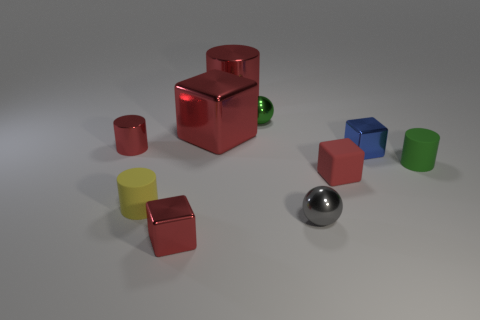Subtract all green spheres. How many red cubes are left? 3 Subtract all cubes. How many objects are left? 6 Add 1 red blocks. How many red blocks exist? 4 Subtract 0 brown balls. How many objects are left? 10 Subtract all big cubes. Subtract all tiny blue cubes. How many objects are left? 8 Add 1 metal objects. How many metal objects are left? 8 